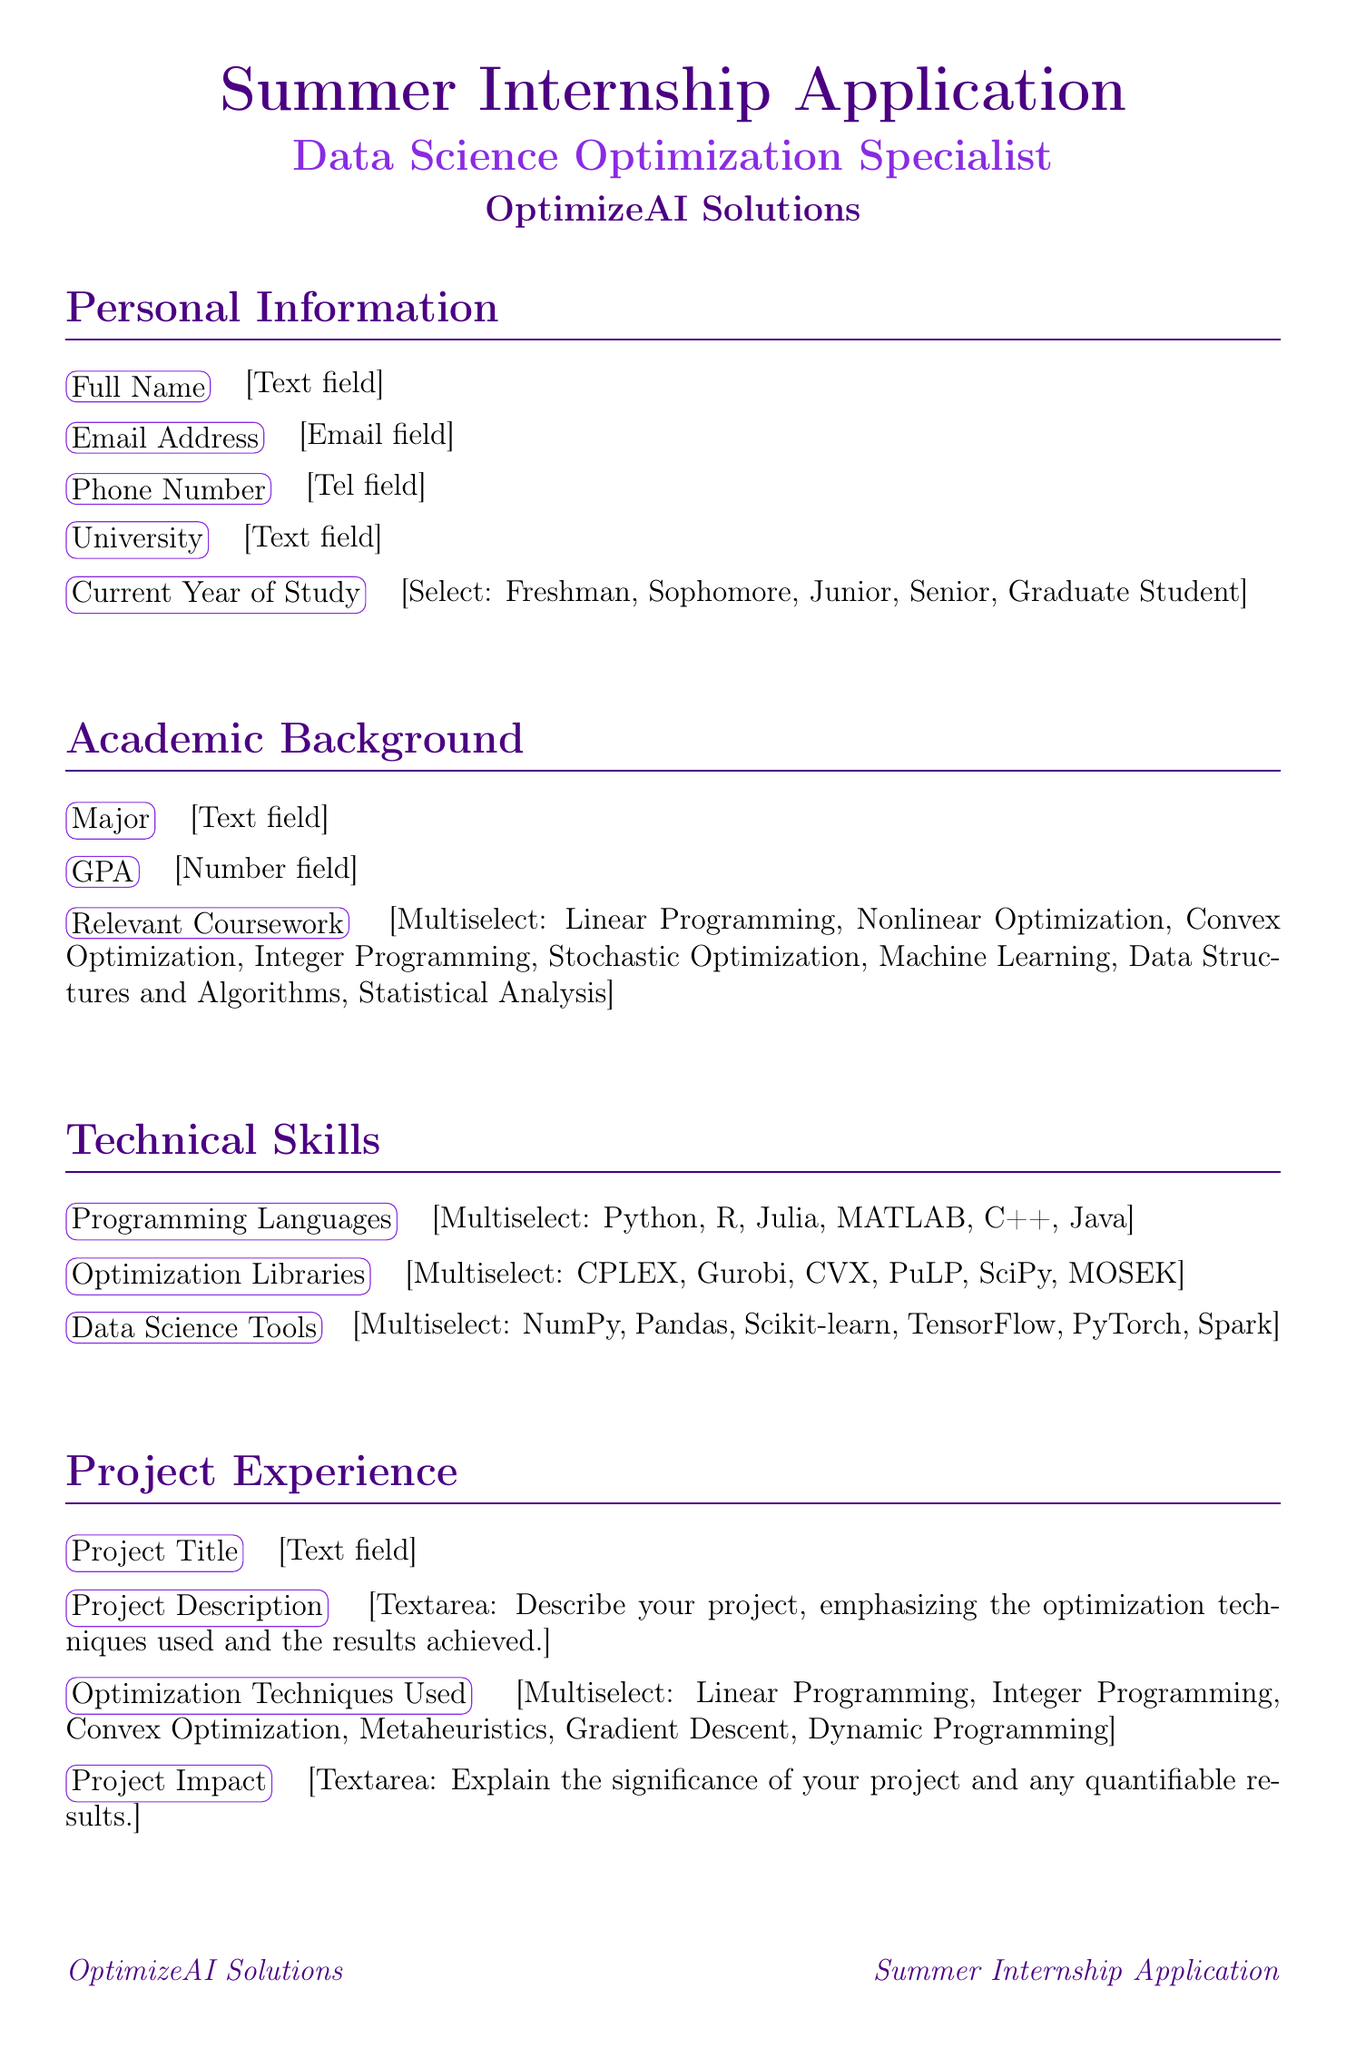What is the title of the internship? The title of the internship is mentioned at the top of the document as "Summer Internship Application - Data Science Optimization Specialist."
Answer: Summer Internship Application - Data Science Optimization Specialist What must be included in the "Project Impact" section? The "Project Impact" section requires an explanation of the significance of the project and any quantifiable results.
Answer: Significance of the project and any quantifiable results How many programming languages can applicants select? The document lists six programming languages for applicants to choose from, indicating the number of options available.
Answer: Six What is one of the required optimization techniques listed in the project experience? The document includes several optimization techniques; one example can be directly pulled from the list provided.
Answer: Linear Programming Which company is the internship application for? The document specifies the company name at the top, which is required to be known by applicants.
Answer: OptimizeAI Solutions What is the maximum number of file formats accepted for the resume/CV upload? The resume/CV section states the accepted formats, which can determine the maximum options provided.
Answer: Three What should applicants explain in the "Motivation Statement"? The "Motivation Statement" section requires applicants to describe their passion for mathematical optimization and its alignment with the company's mission.
Answer: Passion for mathematical optimization and alignment with the company's mission What type of question is included in the "Optimization Challenge" section? The "Optimization Challenge" section contains a challenging question that requires a strategy outline and specific techniques.
Answer: Optimization problem strategy outline What are two options applicants can choose from in their current year of study? The current year of study includes multiple options, and two can be easily selected from the provided list.
Answer: Freshman, Sophomore 